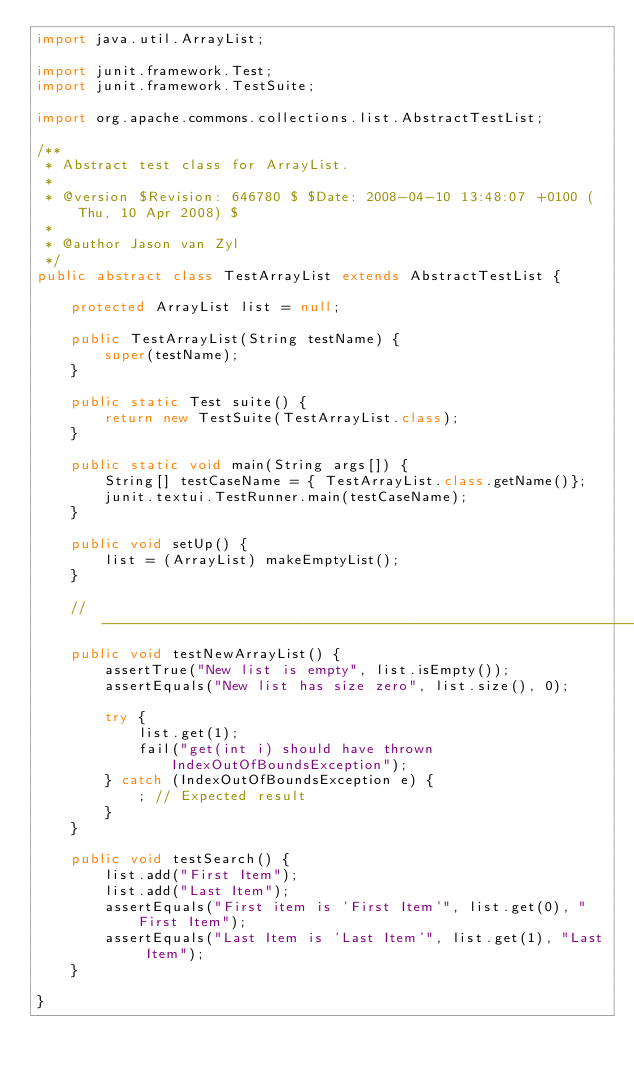Convert code to text. <code><loc_0><loc_0><loc_500><loc_500><_Java_>import java.util.ArrayList;

import junit.framework.Test;
import junit.framework.TestSuite;

import org.apache.commons.collections.list.AbstractTestList;

/**
 * Abstract test class for ArrayList.
 * 
 * @version $Revision: 646780 $ $Date: 2008-04-10 13:48:07 +0100 (Thu, 10 Apr 2008) $
 * 
 * @author Jason van Zyl
 */
public abstract class TestArrayList extends AbstractTestList {
    
    protected ArrayList list = null;
    
    public TestArrayList(String testName) {
        super(testName);
    }

    public static Test suite() {
        return new TestSuite(TestArrayList.class);
    }

    public static void main(String args[]) {
        String[] testCaseName = { TestArrayList.class.getName()};
        junit.textui.TestRunner.main(testCaseName);
    }

    public void setUp() {
        list = (ArrayList) makeEmptyList();
    }

    //-----------------------------------------------------------------------
    public void testNewArrayList() {
        assertTrue("New list is empty", list.isEmpty());
        assertEquals("New list has size zero", list.size(), 0);

        try {
            list.get(1);
            fail("get(int i) should have thrown IndexOutOfBoundsException");
        } catch (IndexOutOfBoundsException e) {
            ; // Expected result
        }
    }

    public void testSearch() {
        list.add("First Item");
        list.add("Last Item");
        assertEquals("First item is 'First Item'", list.get(0), "First Item");
        assertEquals("Last Item is 'Last Item'", list.get(1), "Last Item");
    }

}
</code> 